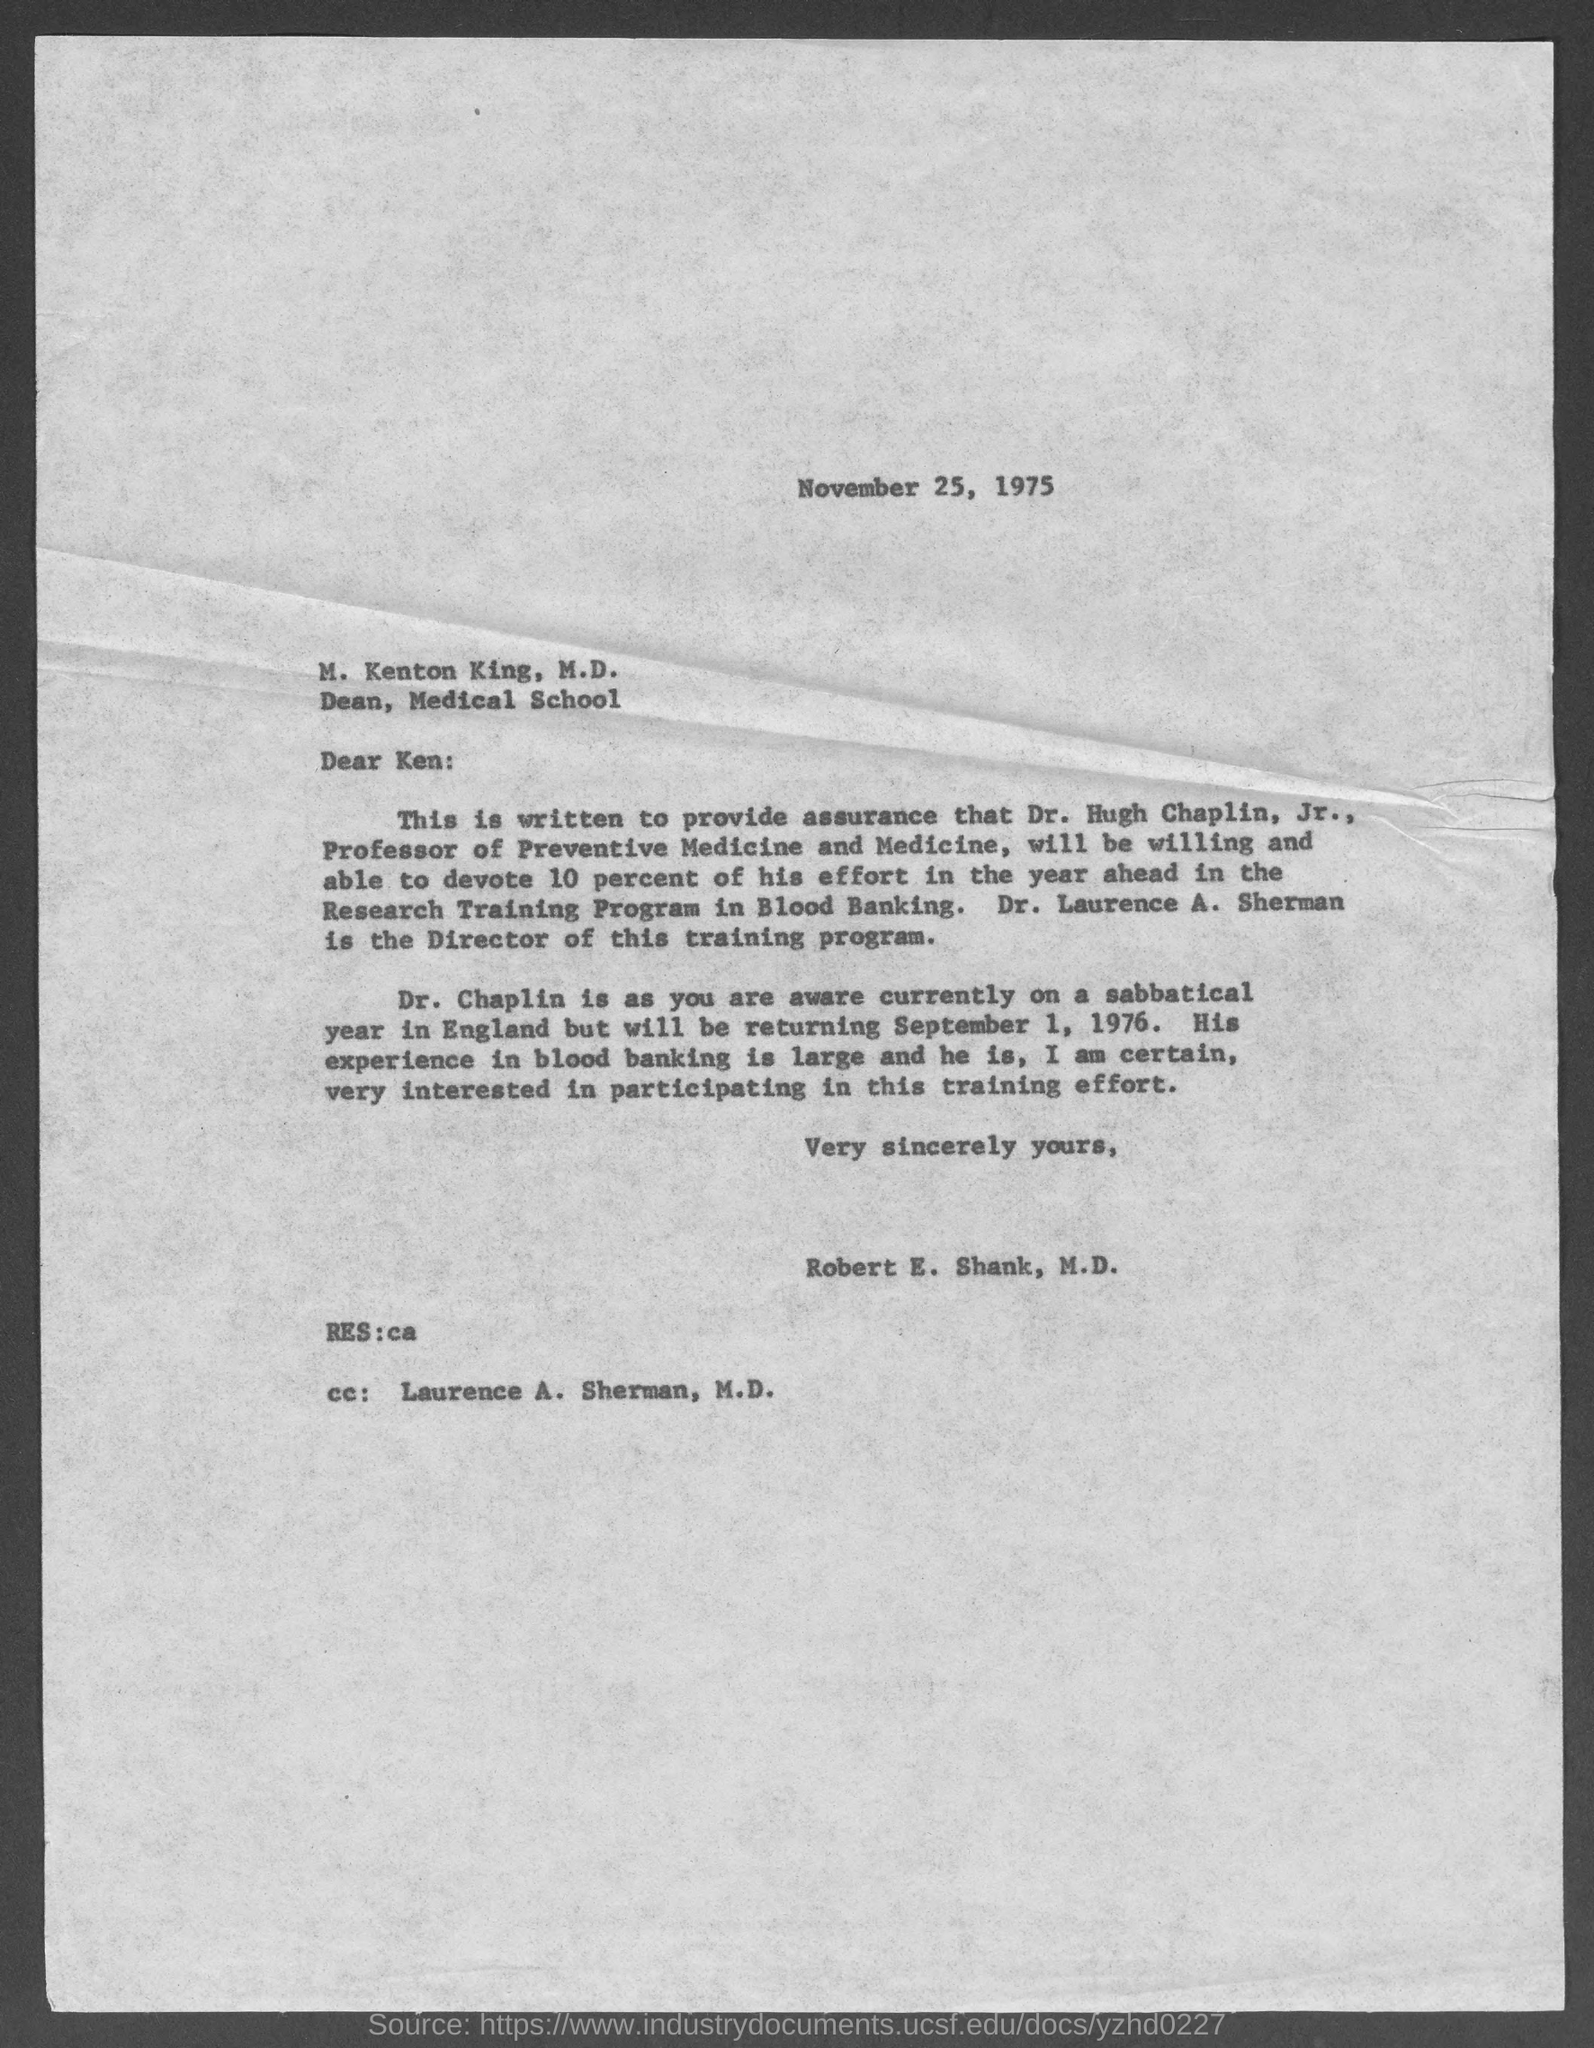Mention a couple of crucial points in this snapshot. The Director of the training program is Dr. Laurence A. Sherman. The date written on the letter is November 25, 1975. 